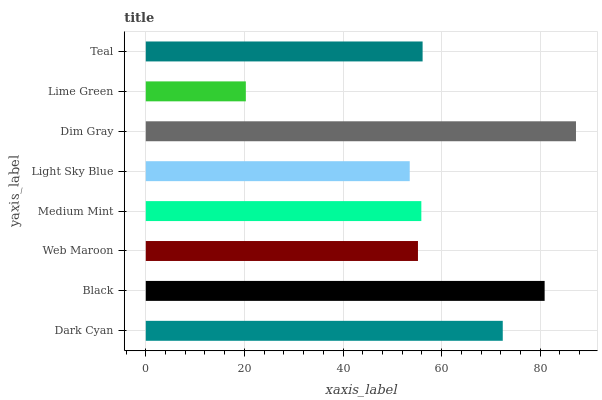Is Lime Green the minimum?
Answer yes or no. Yes. Is Dim Gray the maximum?
Answer yes or no. Yes. Is Black the minimum?
Answer yes or no. No. Is Black the maximum?
Answer yes or no. No. Is Black greater than Dark Cyan?
Answer yes or no. Yes. Is Dark Cyan less than Black?
Answer yes or no. Yes. Is Dark Cyan greater than Black?
Answer yes or no. No. Is Black less than Dark Cyan?
Answer yes or no. No. Is Teal the high median?
Answer yes or no. Yes. Is Medium Mint the low median?
Answer yes or no. Yes. Is Medium Mint the high median?
Answer yes or no. No. Is Dark Cyan the low median?
Answer yes or no. No. 